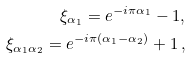Convert formula to latex. <formula><loc_0><loc_0><loc_500><loc_500>\xi _ { \alpha _ { 1 } } = e ^ { - i \pi \alpha _ { 1 } } - 1 , \\ \xi _ { \alpha _ { 1 } \alpha _ { 2 } } = e ^ { - i \pi ( \alpha _ { 1 } - \alpha _ { 2 } ) } + 1 \, ,</formula> 